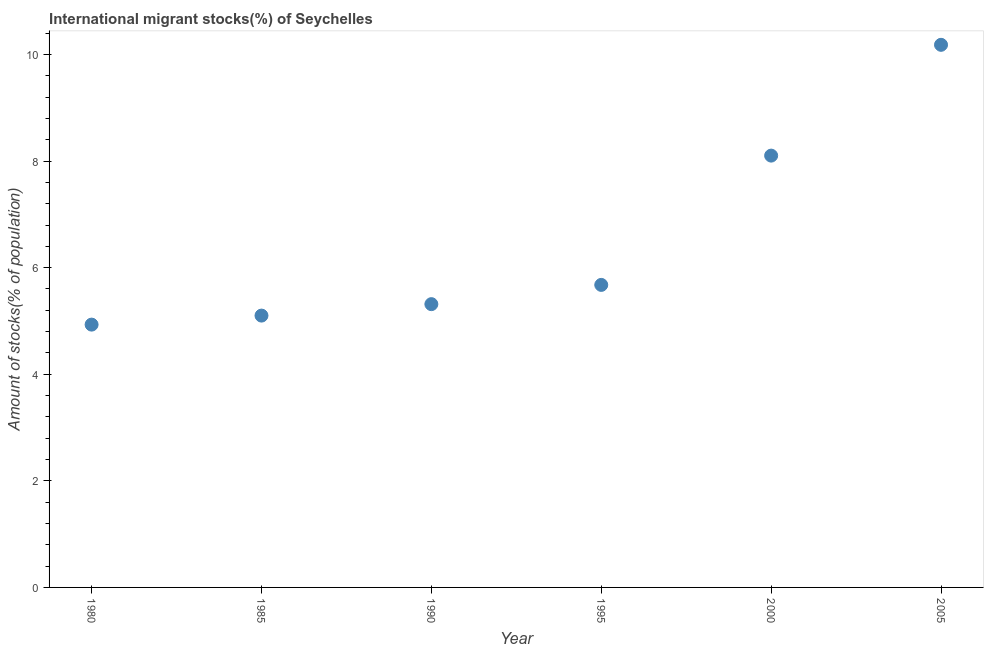What is the number of international migrant stocks in 1985?
Provide a short and direct response. 5.1. Across all years, what is the maximum number of international migrant stocks?
Offer a very short reply. 10.18. Across all years, what is the minimum number of international migrant stocks?
Offer a terse response. 4.93. In which year was the number of international migrant stocks maximum?
Your answer should be very brief. 2005. What is the sum of the number of international migrant stocks?
Your response must be concise. 39.31. What is the difference between the number of international migrant stocks in 1985 and 1990?
Give a very brief answer. -0.21. What is the average number of international migrant stocks per year?
Provide a short and direct response. 6.55. What is the median number of international migrant stocks?
Give a very brief answer. 5.5. What is the ratio of the number of international migrant stocks in 1995 to that in 2000?
Your answer should be very brief. 0.7. What is the difference between the highest and the second highest number of international migrant stocks?
Give a very brief answer. 2.08. Is the sum of the number of international migrant stocks in 1990 and 2000 greater than the maximum number of international migrant stocks across all years?
Your answer should be very brief. Yes. What is the difference between the highest and the lowest number of international migrant stocks?
Provide a short and direct response. 5.25. In how many years, is the number of international migrant stocks greater than the average number of international migrant stocks taken over all years?
Give a very brief answer. 2. What is the difference between two consecutive major ticks on the Y-axis?
Provide a succinct answer. 2. What is the title of the graph?
Provide a short and direct response. International migrant stocks(%) of Seychelles. What is the label or title of the Y-axis?
Ensure brevity in your answer.  Amount of stocks(% of population). What is the Amount of stocks(% of population) in 1980?
Ensure brevity in your answer.  4.93. What is the Amount of stocks(% of population) in 1985?
Your answer should be compact. 5.1. What is the Amount of stocks(% of population) in 1990?
Ensure brevity in your answer.  5.32. What is the Amount of stocks(% of population) in 1995?
Offer a very short reply. 5.68. What is the Amount of stocks(% of population) in 2000?
Provide a succinct answer. 8.1. What is the Amount of stocks(% of population) in 2005?
Provide a succinct answer. 10.18. What is the difference between the Amount of stocks(% of population) in 1980 and 1985?
Your answer should be compact. -0.17. What is the difference between the Amount of stocks(% of population) in 1980 and 1990?
Offer a very short reply. -0.38. What is the difference between the Amount of stocks(% of population) in 1980 and 1995?
Your answer should be compact. -0.75. What is the difference between the Amount of stocks(% of population) in 1980 and 2000?
Your response must be concise. -3.17. What is the difference between the Amount of stocks(% of population) in 1980 and 2005?
Offer a very short reply. -5.25. What is the difference between the Amount of stocks(% of population) in 1985 and 1990?
Offer a very short reply. -0.21. What is the difference between the Amount of stocks(% of population) in 1985 and 1995?
Ensure brevity in your answer.  -0.58. What is the difference between the Amount of stocks(% of population) in 1985 and 2000?
Make the answer very short. -3. What is the difference between the Amount of stocks(% of population) in 1985 and 2005?
Provide a succinct answer. -5.08. What is the difference between the Amount of stocks(% of population) in 1990 and 1995?
Ensure brevity in your answer.  -0.36. What is the difference between the Amount of stocks(% of population) in 1990 and 2000?
Offer a terse response. -2.79. What is the difference between the Amount of stocks(% of population) in 1990 and 2005?
Your answer should be compact. -4.87. What is the difference between the Amount of stocks(% of population) in 1995 and 2000?
Provide a short and direct response. -2.43. What is the difference between the Amount of stocks(% of population) in 1995 and 2005?
Your answer should be very brief. -4.51. What is the difference between the Amount of stocks(% of population) in 2000 and 2005?
Give a very brief answer. -2.08. What is the ratio of the Amount of stocks(% of population) in 1980 to that in 1985?
Give a very brief answer. 0.97. What is the ratio of the Amount of stocks(% of population) in 1980 to that in 1990?
Provide a short and direct response. 0.93. What is the ratio of the Amount of stocks(% of population) in 1980 to that in 1995?
Provide a succinct answer. 0.87. What is the ratio of the Amount of stocks(% of population) in 1980 to that in 2000?
Your response must be concise. 0.61. What is the ratio of the Amount of stocks(% of population) in 1980 to that in 2005?
Your response must be concise. 0.48. What is the ratio of the Amount of stocks(% of population) in 1985 to that in 1995?
Provide a succinct answer. 0.9. What is the ratio of the Amount of stocks(% of population) in 1985 to that in 2000?
Ensure brevity in your answer.  0.63. What is the ratio of the Amount of stocks(% of population) in 1985 to that in 2005?
Your answer should be very brief. 0.5. What is the ratio of the Amount of stocks(% of population) in 1990 to that in 1995?
Keep it short and to the point. 0.94. What is the ratio of the Amount of stocks(% of population) in 1990 to that in 2000?
Offer a very short reply. 0.66. What is the ratio of the Amount of stocks(% of population) in 1990 to that in 2005?
Your answer should be compact. 0.52. What is the ratio of the Amount of stocks(% of population) in 1995 to that in 2000?
Make the answer very short. 0.7. What is the ratio of the Amount of stocks(% of population) in 1995 to that in 2005?
Keep it short and to the point. 0.56. What is the ratio of the Amount of stocks(% of population) in 2000 to that in 2005?
Make the answer very short. 0.8. 